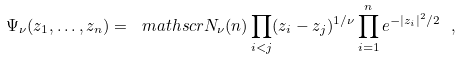<formula> <loc_0><loc_0><loc_500><loc_500>\Psi _ { \nu } ( z _ { 1 } , \dots , z _ { n } ) = \ m a t h s c r { N } _ { \nu } ( n ) \prod _ { i < j } ( z _ { i } - z _ { j } ) ^ { 1 / \nu } \prod _ { i = 1 } ^ { n } e ^ { - | z _ { i } | ^ { 2 } / 2 } \ ,</formula> 